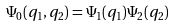Convert formula to latex. <formula><loc_0><loc_0><loc_500><loc_500>\Psi _ { 0 } ( q _ { 1 } , q _ { 2 } ) = \Psi _ { 1 } ( q _ { 1 } ) \Psi _ { 2 } ( q _ { 2 } )</formula> 